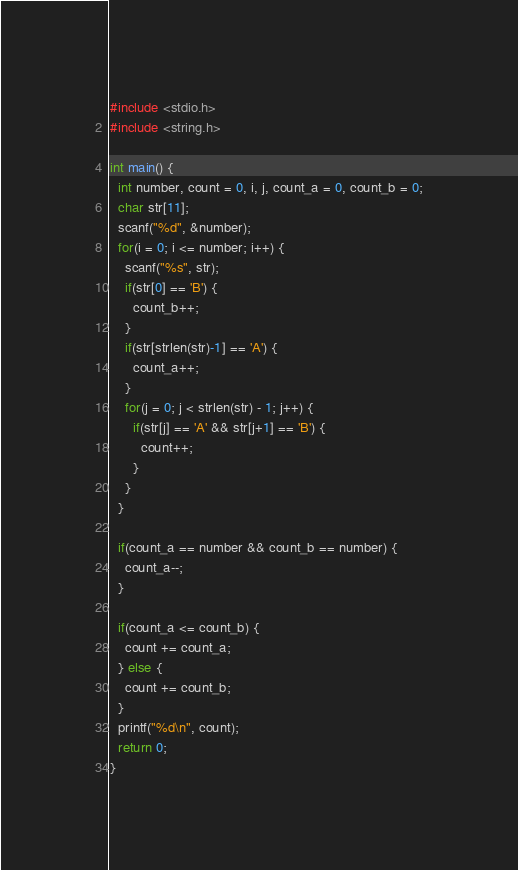<code> <loc_0><loc_0><loc_500><loc_500><_C_>#include <stdio.h>
#include <string.h>

int main() {
  int number, count = 0, i, j, count_a = 0, count_b = 0;
  char str[11];
  scanf("%d", &number);
  for(i = 0; i <= number; i++) {
    scanf("%s", str);
    if(str[0] == 'B') {
      count_b++;
    }
    if(str[strlen(str)-1] == 'A') {
      count_a++;
    }
    for(j = 0; j < strlen(str) - 1; j++) {
      if(str[j] == 'A' && str[j+1] == 'B') {
        count++;
      }
    }
  }

  if(count_a == number && count_b == number) {
    count_a--;
  }

  if(count_a <= count_b) {
    count += count_a;
  } else {
    count += count_b;
  }
  printf("%d\n", count);
  return 0;
}
</code> 